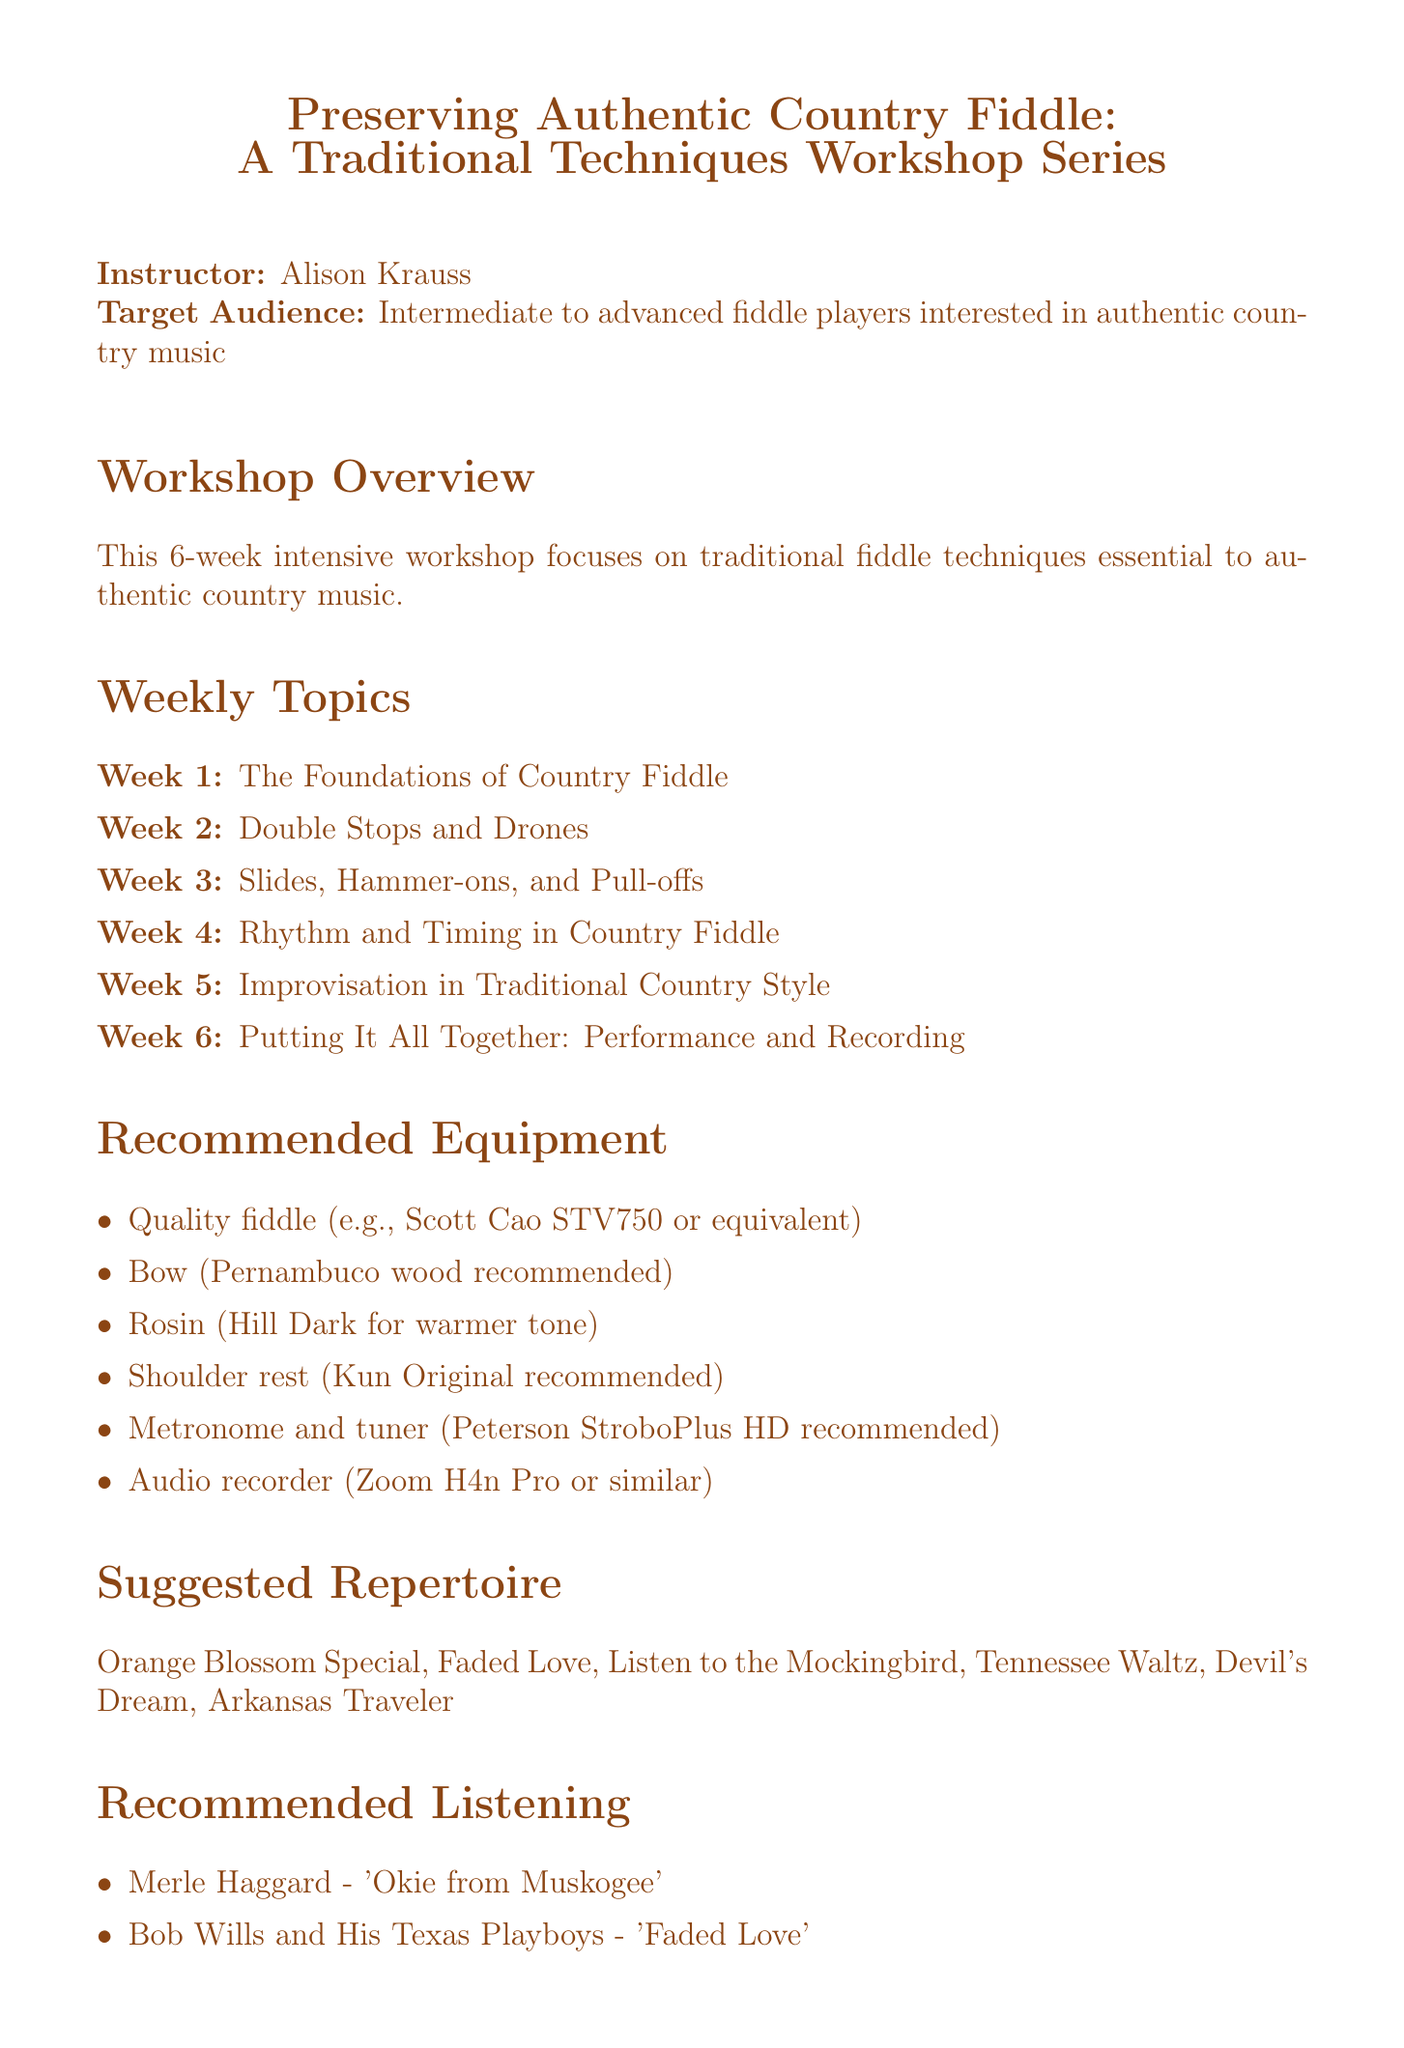What is the instructor's name? The instructor of the workshop is explicitly named in the document as Alison Krauss.
Answer: Alison Krauss How many weeks does the workshop series last? The workshop series is described to last for a total of 6 weeks in the overview section.
Answer: 6 weeks What is the focus of week 3's topic? Week 3 is centered around "Slides, Hammer-ons, and Pull-offs," highlighting specific techniques used in country fiddle.
Answer: Slides, Hammer-ons, and Pull-offs What is the recommended daily practice routine for week 2? The document outlines a daily practice routine for week 2 focusing on specific tunes for 45 minutes.
Answer: 45 minutes daily Which fiddle techniques are covered in week 4? The focus of week 4 is on rhythm and timing techniques specific to the role of the fiddle in country music.
Answer: Rhythm and Timing What type of fiddle is recommended? The document specifically mentions a quality fiddle like the Scott Cao STV750, indicating the importance of the instrument.
Answer: Scott Cao STV750 What genre of music is the workshop aimed at? The workshop targets intermediate to advanced fiddle players interested in a specific genre of music, which is outlined in the introduction.
Answer: Authentic country music How long should the final practice routine be in week 6? In the final week, the practice routine for preparing the final performance is stated to be 2 hours daily.
Answer: 2 hours daily 